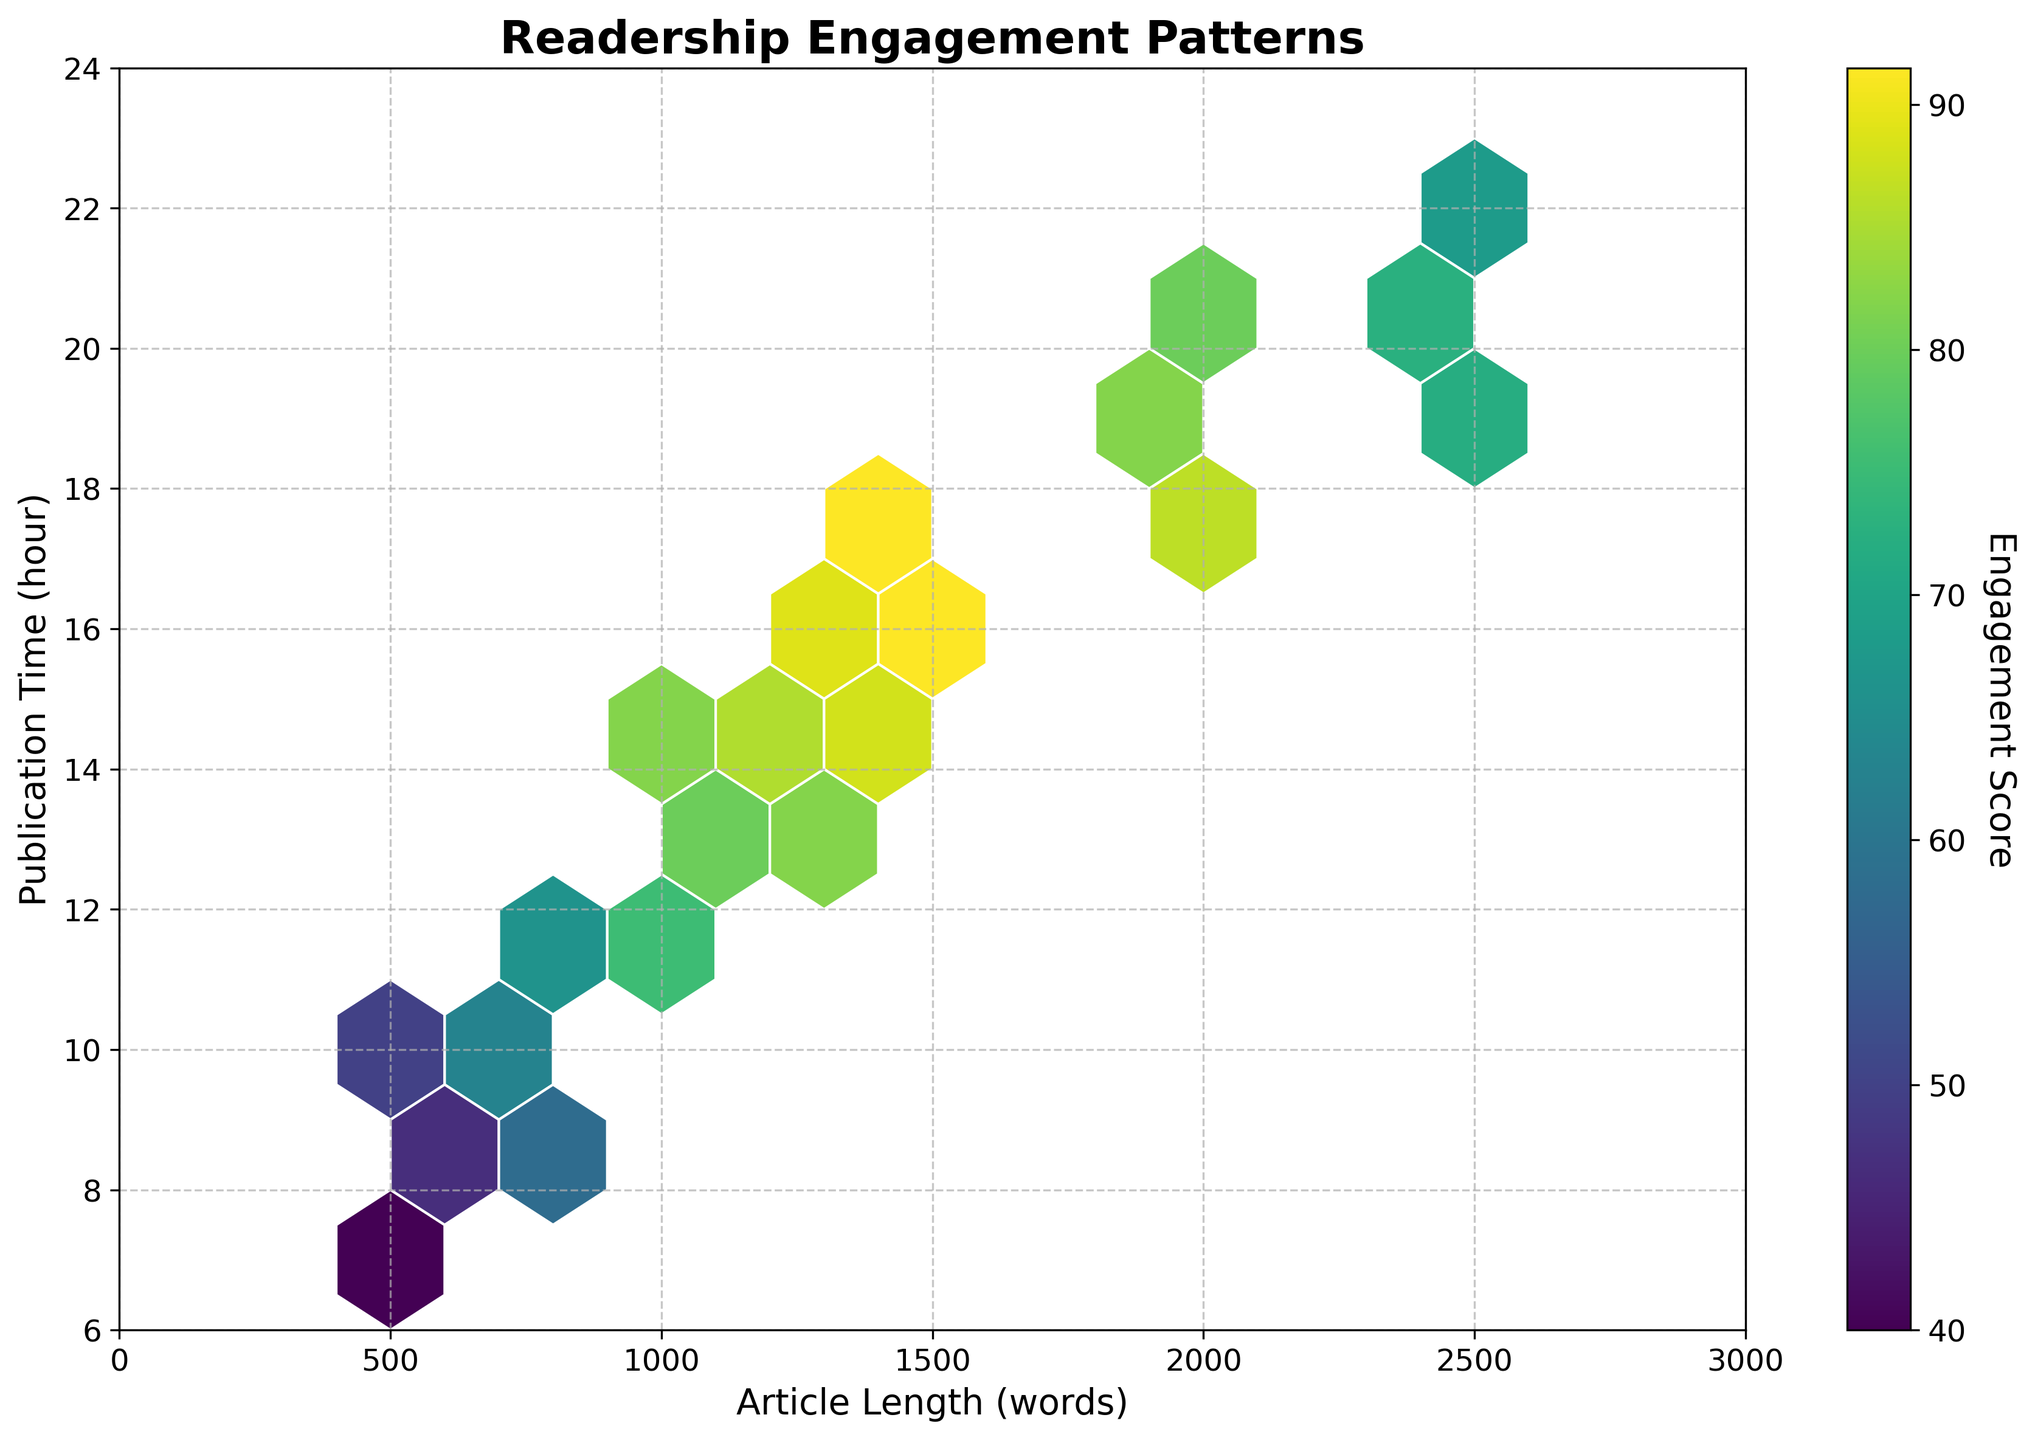How many hexagons are visible on the plot? Count the number of hexagons visually. There are 17 hexagons visible in total.
Answer: 17 What does the color in the hexagons represent? The color of the hexagons represents the engagement score, with the color ranging due to the Viridis colormap used.
Answer: Engagement score What are the labels of the axes? Look at the text beside the horizontal and vertical lines. The x-axis is labeled 'Article Length (words)' and the y-axis is labeled 'Publication Time (hour)'.
Answer: Article Length (words), Publication Time (hour) What is the range of the article lengths shown on the plot? Observing the x-axis labels, the range is from 0 to 3000 words.
Answer: 0 to 3000 words Which publication time appears to have the highest engagement score? Look for the darkest hexagon on the plot. It appears around the 18-hour mark.
Answer: 18-hour mark Are there any publication times with notably low engagement scores? Examine the lightest hexagons on the plot. Times around 20 to 22 hours have some of the lowest engagement scores.
Answer: 20 to 22 hours How does engagement score trend with increasing article length for a publication time of 12 hours? Compare colors of hexagons at 12 hours across different article lengths. Engagement score increases with article length up to a point.
Answer: Increases with article length What is the average publication time among the highest engagement scores? Identify hexagons with the darkest colors and average their y-axis positions. Generally, the engagement score peaks between 14 and 18 hours.
Answer: Between 14 and 18 hours Do shorter articles (500-1000 words) perform better in terms of engagement score at earlier publication times (8-12 hours) or later times (18-22 hours)? Compare the color intensity of hexagons for shorter articles at different times. Engagement scores for shorter articles tend to be higher at earlier times (8-12 hours).
Answer: Earlier times (8-12 hours) Is there any noticeable pattern or correlation between article length and publication time regarding engagement scores? Observe the overall color intensity of hexagons as you move along x and y axes. Higher engagement scores are often seen with articles around 1000-1500 words published around 14-18 hours.
Answer: Yes, higher scores around 1000-1500 words and 14-18 hours 